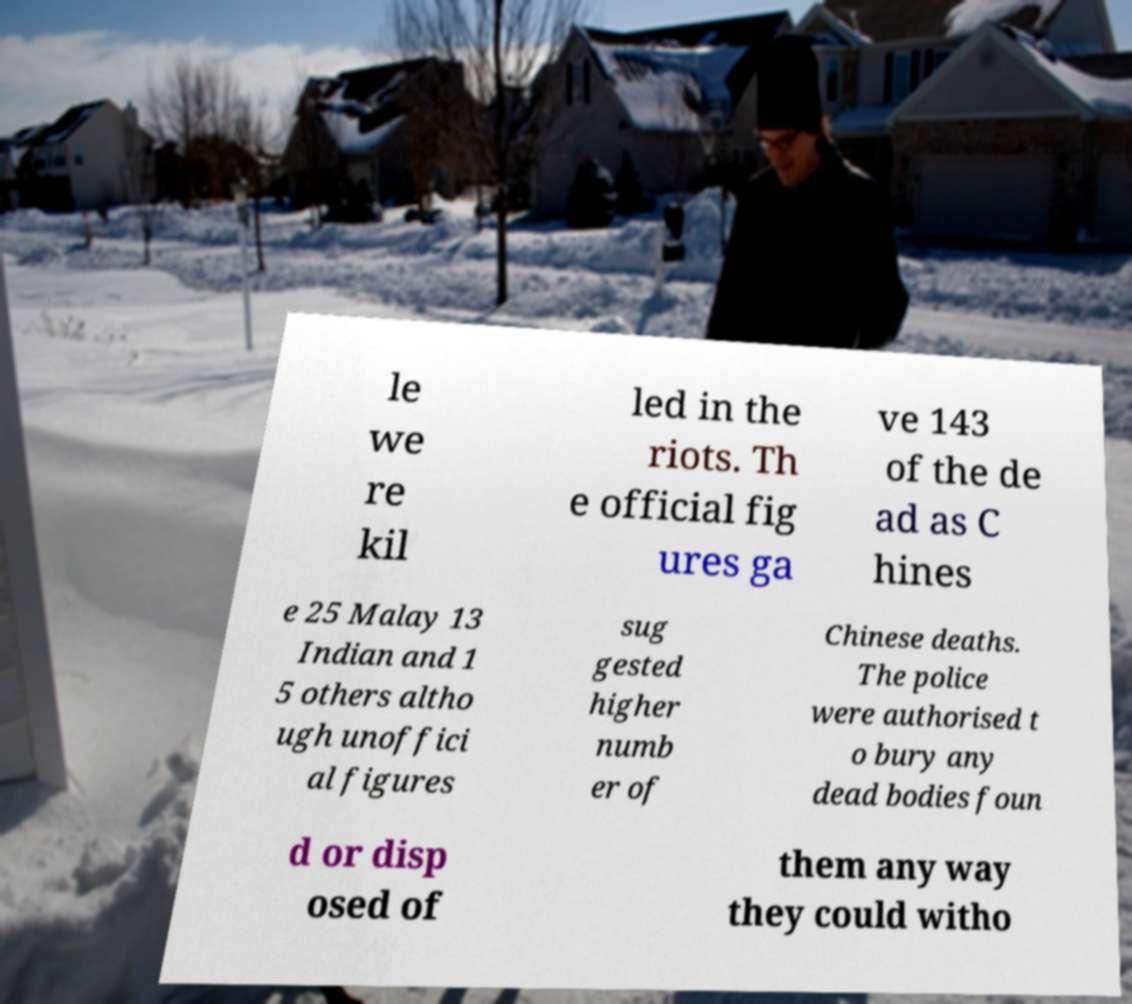There's text embedded in this image that I need extracted. Can you transcribe it verbatim? le we re kil led in the riots. Th e official fig ures ga ve 143 of the de ad as C hines e 25 Malay 13 Indian and 1 5 others altho ugh unoffici al figures sug gested higher numb er of Chinese deaths. The police were authorised t o bury any dead bodies foun d or disp osed of them any way they could witho 